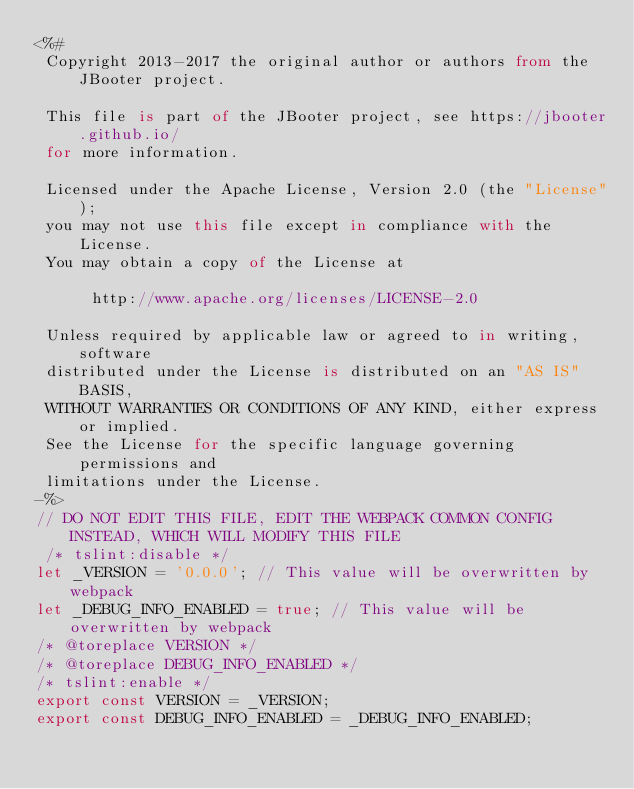<code> <loc_0><loc_0><loc_500><loc_500><_TypeScript_><%#
 Copyright 2013-2017 the original author or authors from the JBooter project.

 This file is part of the JBooter project, see https://jbooter.github.io/
 for more information.

 Licensed under the Apache License, Version 2.0 (the "License");
 you may not use this file except in compliance with the License.
 You may obtain a copy of the License at

      http://www.apache.org/licenses/LICENSE-2.0

 Unless required by applicable law or agreed to in writing, software
 distributed under the License is distributed on an "AS IS" BASIS,
 WITHOUT WARRANTIES OR CONDITIONS OF ANY KIND, either express or implied.
 See the License for the specific language governing permissions and
 limitations under the License.
-%>
// DO NOT EDIT THIS FILE, EDIT THE WEBPACK COMMON CONFIG INSTEAD, WHICH WILL MODIFY THIS FILE
 /* tslint:disable */
let _VERSION = '0.0.0'; // This value will be overwritten by webpack
let _DEBUG_INFO_ENABLED = true; // This value will be overwritten by webpack
/* @toreplace VERSION */
/* @toreplace DEBUG_INFO_ENABLED */
/* tslint:enable */
export const VERSION = _VERSION;
export const DEBUG_INFO_ENABLED = _DEBUG_INFO_ENABLED;
</code> 